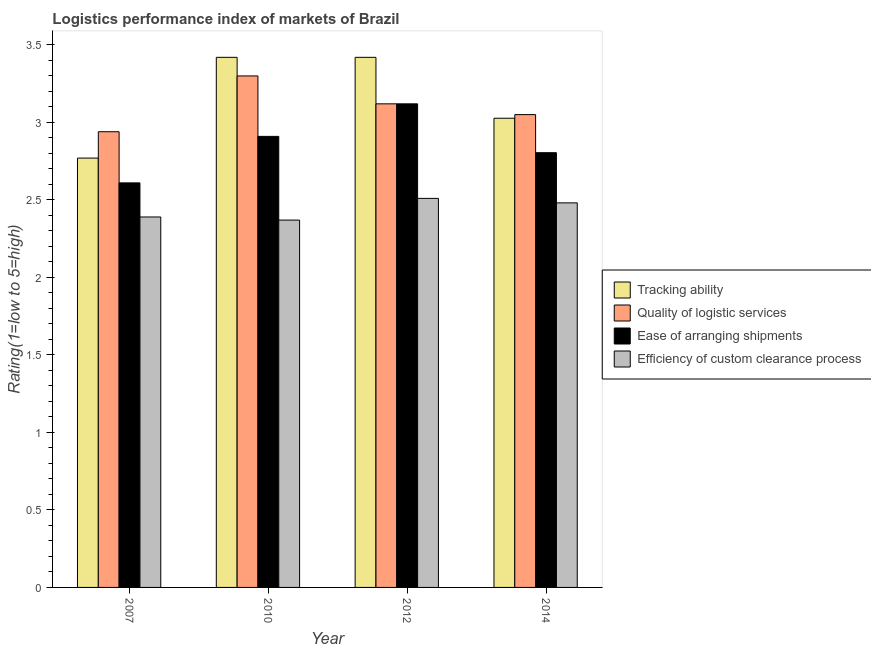How many different coloured bars are there?
Offer a very short reply. 4. Are the number of bars on each tick of the X-axis equal?
Keep it short and to the point. Yes. What is the label of the 4th group of bars from the left?
Your answer should be very brief. 2014. What is the lpi rating of efficiency of custom clearance process in 2012?
Ensure brevity in your answer.  2.51. Across all years, what is the maximum lpi rating of efficiency of custom clearance process?
Provide a succinct answer. 2.51. Across all years, what is the minimum lpi rating of quality of logistic services?
Make the answer very short. 2.94. In which year was the lpi rating of efficiency of custom clearance process maximum?
Your response must be concise. 2012. In which year was the lpi rating of ease of arranging shipments minimum?
Your answer should be compact. 2007. What is the total lpi rating of tracking ability in the graph?
Offer a very short reply. 12.64. What is the difference between the lpi rating of efficiency of custom clearance process in 2010 and that in 2012?
Offer a terse response. -0.14. What is the difference between the lpi rating of tracking ability in 2014 and the lpi rating of quality of logistic services in 2007?
Offer a terse response. 0.26. What is the average lpi rating of efficiency of custom clearance process per year?
Your answer should be compact. 2.44. In the year 2010, what is the difference between the lpi rating of tracking ability and lpi rating of ease of arranging shipments?
Keep it short and to the point. 0. In how many years, is the lpi rating of ease of arranging shipments greater than 2.8?
Ensure brevity in your answer.  3. What is the ratio of the lpi rating of quality of logistic services in 2010 to that in 2012?
Your answer should be compact. 1.06. Is the difference between the lpi rating of ease of arranging shipments in 2012 and 2014 greater than the difference between the lpi rating of tracking ability in 2012 and 2014?
Give a very brief answer. No. What is the difference between the highest and the second highest lpi rating of ease of arranging shipments?
Your response must be concise. 0.21. What is the difference between the highest and the lowest lpi rating of tracking ability?
Provide a short and direct response. 0.65. In how many years, is the lpi rating of tracking ability greater than the average lpi rating of tracking ability taken over all years?
Provide a succinct answer. 2. Is it the case that in every year, the sum of the lpi rating of ease of arranging shipments and lpi rating of tracking ability is greater than the sum of lpi rating of efficiency of custom clearance process and lpi rating of quality of logistic services?
Give a very brief answer. No. What does the 4th bar from the left in 2012 represents?
Give a very brief answer. Efficiency of custom clearance process. What does the 3rd bar from the right in 2012 represents?
Provide a succinct answer. Quality of logistic services. Is it the case that in every year, the sum of the lpi rating of tracking ability and lpi rating of quality of logistic services is greater than the lpi rating of ease of arranging shipments?
Your response must be concise. Yes. How many bars are there?
Your answer should be compact. 16. Are all the bars in the graph horizontal?
Make the answer very short. No. Are the values on the major ticks of Y-axis written in scientific E-notation?
Ensure brevity in your answer.  No. Where does the legend appear in the graph?
Provide a succinct answer. Center right. How are the legend labels stacked?
Your answer should be very brief. Vertical. What is the title of the graph?
Your answer should be very brief. Logistics performance index of markets of Brazil. Does "Japan" appear as one of the legend labels in the graph?
Provide a short and direct response. No. What is the label or title of the Y-axis?
Provide a succinct answer. Rating(1=low to 5=high). What is the Rating(1=low to 5=high) of Tracking ability in 2007?
Keep it short and to the point. 2.77. What is the Rating(1=low to 5=high) in Quality of logistic services in 2007?
Provide a succinct answer. 2.94. What is the Rating(1=low to 5=high) in Ease of arranging shipments in 2007?
Offer a very short reply. 2.61. What is the Rating(1=low to 5=high) in Efficiency of custom clearance process in 2007?
Offer a terse response. 2.39. What is the Rating(1=low to 5=high) in Tracking ability in 2010?
Offer a very short reply. 3.42. What is the Rating(1=low to 5=high) in Quality of logistic services in 2010?
Your answer should be very brief. 3.3. What is the Rating(1=low to 5=high) of Ease of arranging shipments in 2010?
Provide a short and direct response. 2.91. What is the Rating(1=low to 5=high) in Efficiency of custom clearance process in 2010?
Provide a short and direct response. 2.37. What is the Rating(1=low to 5=high) of Tracking ability in 2012?
Give a very brief answer. 3.42. What is the Rating(1=low to 5=high) of Quality of logistic services in 2012?
Provide a succinct answer. 3.12. What is the Rating(1=low to 5=high) of Ease of arranging shipments in 2012?
Your answer should be compact. 3.12. What is the Rating(1=low to 5=high) of Efficiency of custom clearance process in 2012?
Your response must be concise. 2.51. What is the Rating(1=low to 5=high) in Tracking ability in 2014?
Make the answer very short. 3.03. What is the Rating(1=low to 5=high) of Quality of logistic services in 2014?
Keep it short and to the point. 3.05. What is the Rating(1=low to 5=high) in Ease of arranging shipments in 2014?
Offer a very short reply. 2.8. What is the Rating(1=low to 5=high) in Efficiency of custom clearance process in 2014?
Offer a very short reply. 2.48. Across all years, what is the maximum Rating(1=low to 5=high) of Tracking ability?
Your response must be concise. 3.42. Across all years, what is the maximum Rating(1=low to 5=high) in Ease of arranging shipments?
Your answer should be very brief. 3.12. Across all years, what is the maximum Rating(1=low to 5=high) in Efficiency of custom clearance process?
Provide a succinct answer. 2.51. Across all years, what is the minimum Rating(1=low to 5=high) in Tracking ability?
Give a very brief answer. 2.77. Across all years, what is the minimum Rating(1=low to 5=high) in Quality of logistic services?
Your answer should be compact. 2.94. Across all years, what is the minimum Rating(1=low to 5=high) in Ease of arranging shipments?
Your answer should be compact. 2.61. Across all years, what is the minimum Rating(1=low to 5=high) of Efficiency of custom clearance process?
Your answer should be very brief. 2.37. What is the total Rating(1=low to 5=high) of Tracking ability in the graph?
Your answer should be compact. 12.64. What is the total Rating(1=low to 5=high) in Quality of logistic services in the graph?
Offer a very short reply. 12.41. What is the total Rating(1=low to 5=high) in Ease of arranging shipments in the graph?
Provide a succinct answer. 11.44. What is the total Rating(1=low to 5=high) in Efficiency of custom clearance process in the graph?
Your answer should be very brief. 9.75. What is the difference between the Rating(1=low to 5=high) of Tracking ability in 2007 and that in 2010?
Offer a terse response. -0.65. What is the difference between the Rating(1=low to 5=high) of Quality of logistic services in 2007 and that in 2010?
Offer a terse response. -0.36. What is the difference between the Rating(1=low to 5=high) in Ease of arranging shipments in 2007 and that in 2010?
Make the answer very short. -0.3. What is the difference between the Rating(1=low to 5=high) of Tracking ability in 2007 and that in 2012?
Give a very brief answer. -0.65. What is the difference between the Rating(1=low to 5=high) in Quality of logistic services in 2007 and that in 2012?
Your answer should be compact. -0.18. What is the difference between the Rating(1=low to 5=high) of Ease of arranging shipments in 2007 and that in 2012?
Keep it short and to the point. -0.51. What is the difference between the Rating(1=low to 5=high) of Efficiency of custom clearance process in 2007 and that in 2012?
Keep it short and to the point. -0.12. What is the difference between the Rating(1=low to 5=high) in Tracking ability in 2007 and that in 2014?
Ensure brevity in your answer.  -0.26. What is the difference between the Rating(1=low to 5=high) in Quality of logistic services in 2007 and that in 2014?
Your response must be concise. -0.11. What is the difference between the Rating(1=low to 5=high) in Ease of arranging shipments in 2007 and that in 2014?
Offer a very short reply. -0.19. What is the difference between the Rating(1=low to 5=high) in Efficiency of custom clearance process in 2007 and that in 2014?
Ensure brevity in your answer.  -0.09. What is the difference between the Rating(1=low to 5=high) in Quality of logistic services in 2010 and that in 2012?
Make the answer very short. 0.18. What is the difference between the Rating(1=low to 5=high) in Ease of arranging shipments in 2010 and that in 2012?
Your response must be concise. -0.21. What is the difference between the Rating(1=low to 5=high) in Efficiency of custom clearance process in 2010 and that in 2012?
Give a very brief answer. -0.14. What is the difference between the Rating(1=low to 5=high) of Tracking ability in 2010 and that in 2014?
Ensure brevity in your answer.  0.39. What is the difference between the Rating(1=low to 5=high) of Quality of logistic services in 2010 and that in 2014?
Your answer should be compact. 0.25. What is the difference between the Rating(1=low to 5=high) of Ease of arranging shipments in 2010 and that in 2014?
Keep it short and to the point. 0.11. What is the difference between the Rating(1=low to 5=high) of Efficiency of custom clearance process in 2010 and that in 2014?
Your answer should be compact. -0.11. What is the difference between the Rating(1=low to 5=high) in Tracking ability in 2012 and that in 2014?
Make the answer very short. 0.39. What is the difference between the Rating(1=low to 5=high) in Quality of logistic services in 2012 and that in 2014?
Offer a very short reply. 0.07. What is the difference between the Rating(1=low to 5=high) in Ease of arranging shipments in 2012 and that in 2014?
Give a very brief answer. 0.32. What is the difference between the Rating(1=low to 5=high) of Efficiency of custom clearance process in 2012 and that in 2014?
Ensure brevity in your answer.  0.03. What is the difference between the Rating(1=low to 5=high) in Tracking ability in 2007 and the Rating(1=low to 5=high) in Quality of logistic services in 2010?
Your answer should be compact. -0.53. What is the difference between the Rating(1=low to 5=high) in Tracking ability in 2007 and the Rating(1=low to 5=high) in Ease of arranging shipments in 2010?
Give a very brief answer. -0.14. What is the difference between the Rating(1=low to 5=high) in Tracking ability in 2007 and the Rating(1=low to 5=high) in Efficiency of custom clearance process in 2010?
Offer a terse response. 0.4. What is the difference between the Rating(1=low to 5=high) of Quality of logistic services in 2007 and the Rating(1=low to 5=high) of Efficiency of custom clearance process in 2010?
Provide a short and direct response. 0.57. What is the difference between the Rating(1=low to 5=high) of Ease of arranging shipments in 2007 and the Rating(1=low to 5=high) of Efficiency of custom clearance process in 2010?
Your answer should be compact. 0.24. What is the difference between the Rating(1=low to 5=high) in Tracking ability in 2007 and the Rating(1=low to 5=high) in Quality of logistic services in 2012?
Give a very brief answer. -0.35. What is the difference between the Rating(1=low to 5=high) of Tracking ability in 2007 and the Rating(1=low to 5=high) of Ease of arranging shipments in 2012?
Provide a succinct answer. -0.35. What is the difference between the Rating(1=low to 5=high) in Tracking ability in 2007 and the Rating(1=low to 5=high) in Efficiency of custom clearance process in 2012?
Provide a succinct answer. 0.26. What is the difference between the Rating(1=low to 5=high) of Quality of logistic services in 2007 and the Rating(1=low to 5=high) of Ease of arranging shipments in 2012?
Offer a terse response. -0.18. What is the difference between the Rating(1=low to 5=high) of Quality of logistic services in 2007 and the Rating(1=low to 5=high) of Efficiency of custom clearance process in 2012?
Offer a terse response. 0.43. What is the difference between the Rating(1=low to 5=high) in Ease of arranging shipments in 2007 and the Rating(1=low to 5=high) in Efficiency of custom clearance process in 2012?
Give a very brief answer. 0.1. What is the difference between the Rating(1=low to 5=high) of Tracking ability in 2007 and the Rating(1=low to 5=high) of Quality of logistic services in 2014?
Ensure brevity in your answer.  -0.28. What is the difference between the Rating(1=low to 5=high) of Tracking ability in 2007 and the Rating(1=low to 5=high) of Ease of arranging shipments in 2014?
Offer a terse response. -0.03. What is the difference between the Rating(1=low to 5=high) in Tracking ability in 2007 and the Rating(1=low to 5=high) in Efficiency of custom clearance process in 2014?
Offer a terse response. 0.29. What is the difference between the Rating(1=low to 5=high) of Quality of logistic services in 2007 and the Rating(1=low to 5=high) of Ease of arranging shipments in 2014?
Provide a short and direct response. 0.14. What is the difference between the Rating(1=low to 5=high) of Quality of logistic services in 2007 and the Rating(1=low to 5=high) of Efficiency of custom clearance process in 2014?
Make the answer very short. 0.46. What is the difference between the Rating(1=low to 5=high) in Ease of arranging shipments in 2007 and the Rating(1=low to 5=high) in Efficiency of custom clearance process in 2014?
Offer a terse response. 0.13. What is the difference between the Rating(1=low to 5=high) of Tracking ability in 2010 and the Rating(1=low to 5=high) of Quality of logistic services in 2012?
Your answer should be compact. 0.3. What is the difference between the Rating(1=low to 5=high) of Tracking ability in 2010 and the Rating(1=low to 5=high) of Ease of arranging shipments in 2012?
Make the answer very short. 0.3. What is the difference between the Rating(1=low to 5=high) in Tracking ability in 2010 and the Rating(1=low to 5=high) in Efficiency of custom clearance process in 2012?
Make the answer very short. 0.91. What is the difference between the Rating(1=low to 5=high) of Quality of logistic services in 2010 and the Rating(1=low to 5=high) of Ease of arranging shipments in 2012?
Your answer should be very brief. 0.18. What is the difference between the Rating(1=low to 5=high) of Quality of logistic services in 2010 and the Rating(1=low to 5=high) of Efficiency of custom clearance process in 2012?
Offer a terse response. 0.79. What is the difference between the Rating(1=low to 5=high) of Tracking ability in 2010 and the Rating(1=low to 5=high) of Quality of logistic services in 2014?
Offer a terse response. 0.37. What is the difference between the Rating(1=low to 5=high) in Tracking ability in 2010 and the Rating(1=low to 5=high) in Ease of arranging shipments in 2014?
Provide a short and direct response. 0.62. What is the difference between the Rating(1=low to 5=high) in Tracking ability in 2010 and the Rating(1=low to 5=high) in Efficiency of custom clearance process in 2014?
Provide a short and direct response. 0.94. What is the difference between the Rating(1=low to 5=high) of Quality of logistic services in 2010 and the Rating(1=low to 5=high) of Ease of arranging shipments in 2014?
Your response must be concise. 0.5. What is the difference between the Rating(1=low to 5=high) of Quality of logistic services in 2010 and the Rating(1=low to 5=high) of Efficiency of custom clearance process in 2014?
Keep it short and to the point. 0.82. What is the difference between the Rating(1=low to 5=high) of Ease of arranging shipments in 2010 and the Rating(1=low to 5=high) of Efficiency of custom clearance process in 2014?
Keep it short and to the point. 0.43. What is the difference between the Rating(1=low to 5=high) in Tracking ability in 2012 and the Rating(1=low to 5=high) in Quality of logistic services in 2014?
Ensure brevity in your answer.  0.37. What is the difference between the Rating(1=low to 5=high) of Tracking ability in 2012 and the Rating(1=low to 5=high) of Ease of arranging shipments in 2014?
Offer a terse response. 0.62. What is the difference between the Rating(1=low to 5=high) in Tracking ability in 2012 and the Rating(1=low to 5=high) in Efficiency of custom clearance process in 2014?
Make the answer very short. 0.94. What is the difference between the Rating(1=low to 5=high) in Quality of logistic services in 2012 and the Rating(1=low to 5=high) in Ease of arranging shipments in 2014?
Offer a terse response. 0.32. What is the difference between the Rating(1=low to 5=high) in Quality of logistic services in 2012 and the Rating(1=low to 5=high) in Efficiency of custom clearance process in 2014?
Keep it short and to the point. 0.64. What is the difference between the Rating(1=low to 5=high) in Ease of arranging shipments in 2012 and the Rating(1=low to 5=high) in Efficiency of custom clearance process in 2014?
Ensure brevity in your answer.  0.64. What is the average Rating(1=low to 5=high) of Tracking ability per year?
Your response must be concise. 3.16. What is the average Rating(1=low to 5=high) in Quality of logistic services per year?
Offer a very short reply. 3.1. What is the average Rating(1=low to 5=high) in Ease of arranging shipments per year?
Your response must be concise. 2.86. What is the average Rating(1=low to 5=high) of Efficiency of custom clearance process per year?
Give a very brief answer. 2.44. In the year 2007, what is the difference between the Rating(1=low to 5=high) of Tracking ability and Rating(1=low to 5=high) of Quality of logistic services?
Your answer should be very brief. -0.17. In the year 2007, what is the difference between the Rating(1=low to 5=high) in Tracking ability and Rating(1=low to 5=high) in Ease of arranging shipments?
Your response must be concise. 0.16. In the year 2007, what is the difference between the Rating(1=low to 5=high) in Tracking ability and Rating(1=low to 5=high) in Efficiency of custom clearance process?
Your response must be concise. 0.38. In the year 2007, what is the difference between the Rating(1=low to 5=high) of Quality of logistic services and Rating(1=low to 5=high) of Ease of arranging shipments?
Offer a very short reply. 0.33. In the year 2007, what is the difference between the Rating(1=low to 5=high) of Quality of logistic services and Rating(1=low to 5=high) of Efficiency of custom clearance process?
Offer a terse response. 0.55. In the year 2007, what is the difference between the Rating(1=low to 5=high) in Ease of arranging shipments and Rating(1=low to 5=high) in Efficiency of custom clearance process?
Offer a terse response. 0.22. In the year 2010, what is the difference between the Rating(1=low to 5=high) of Tracking ability and Rating(1=low to 5=high) of Quality of logistic services?
Provide a succinct answer. 0.12. In the year 2010, what is the difference between the Rating(1=low to 5=high) of Tracking ability and Rating(1=low to 5=high) of Ease of arranging shipments?
Make the answer very short. 0.51. In the year 2010, what is the difference between the Rating(1=low to 5=high) in Quality of logistic services and Rating(1=low to 5=high) in Ease of arranging shipments?
Make the answer very short. 0.39. In the year 2010, what is the difference between the Rating(1=low to 5=high) of Ease of arranging shipments and Rating(1=low to 5=high) of Efficiency of custom clearance process?
Ensure brevity in your answer.  0.54. In the year 2012, what is the difference between the Rating(1=low to 5=high) in Tracking ability and Rating(1=low to 5=high) in Quality of logistic services?
Your answer should be compact. 0.3. In the year 2012, what is the difference between the Rating(1=low to 5=high) of Tracking ability and Rating(1=low to 5=high) of Ease of arranging shipments?
Offer a very short reply. 0.3. In the year 2012, what is the difference between the Rating(1=low to 5=high) in Tracking ability and Rating(1=low to 5=high) in Efficiency of custom clearance process?
Provide a short and direct response. 0.91. In the year 2012, what is the difference between the Rating(1=low to 5=high) of Quality of logistic services and Rating(1=low to 5=high) of Ease of arranging shipments?
Give a very brief answer. 0. In the year 2012, what is the difference between the Rating(1=low to 5=high) in Quality of logistic services and Rating(1=low to 5=high) in Efficiency of custom clearance process?
Ensure brevity in your answer.  0.61. In the year 2012, what is the difference between the Rating(1=low to 5=high) in Ease of arranging shipments and Rating(1=low to 5=high) in Efficiency of custom clearance process?
Make the answer very short. 0.61. In the year 2014, what is the difference between the Rating(1=low to 5=high) in Tracking ability and Rating(1=low to 5=high) in Quality of logistic services?
Offer a terse response. -0.02. In the year 2014, what is the difference between the Rating(1=low to 5=high) in Tracking ability and Rating(1=low to 5=high) in Ease of arranging shipments?
Make the answer very short. 0.22. In the year 2014, what is the difference between the Rating(1=low to 5=high) in Tracking ability and Rating(1=low to 5=high) in Efficiency of custom clearance process?
Keep it short and to the point. 0.55. In the year 2014, what is the difference between the Rating(1=low to 5=high) in Quality of logistic services and Rating(1=low to 5=high) in Ease of arranging shipments?
Give a very brief answer. 0.25. In the year 2014, what is the difference between the Rating(1=low to 5=high) of Quality of logistic services and Rating(1=low to 5=high) of Efficiency of custom clearance process?
Your answer should be compact. 0.57. In the year 2014, what is the difference between the Rating(1=low to 5=high) of Ease of arranging shipments and Rating(1=low to 5=high) of Efficiency of custom clearance process?
Offer a terse response. 0.32. What is the ratio of the Rating(1=low to 5=high) in Tracking ability in 2007 to that in 2010?
Offer a terse response. 0.81. What is the ratio of the Rating(1=low to 5=high) of Quality of logistic services in 2007 to that in 2010?
Your answer should be very brief. 0.89. What is the ratio of the Rating(1=low to 5=high) in Ease of arranging shipments in 2007 to that in 2010?
Give a very brief answer. 0.9. What is the ratio of the Rating(1=low to 5=high) of Efficiency of custom clearance process in 2007 to that in 2010?
Give a very brief answer. 1.01. What is the ratio of the Rating(1=low to 5=high) of Tracking ability in 2007 to that in 2012?
Your response must be concise. 0.81. What is the ratio of the Rating(1=low to 5=high) of Quality of logistic services in 2007 to that in 2012?
Provide a succinct answer. 0.94. What is the ratio of the Rating(1=low to 5=high) in Ease of arranging shipments in 2007 to that in 2012?
Make the answer very short. 0.84. What is the ratio of the Rating(1=low to 5=high) of Efficiency of custom clearance process in 2007 to that in 2012?
Provide a succinct answer. 0.95. What is the ratio of the Rating(1=low to 5=high) of Tracking ability in 2007 to that in 2014?
Your answer should be very brief. 0.92. What is the ratio of the Rating(1=low to 5=high) of Quality of logistic services in 2007 to that in 2014?
Provide a short and direct response. 0.96. What is the ratio of the Rating(1=low to 5=high) of Ease of arranging shipments in 2007 to that in 2014?
Your answer should be very brief. 0.93. What is the ratio of the Rating(1=low to 5=high) of Efficiency of custom clearance process in 2007 to that in 2014?
Give a very brief answer. 0.96. What is the ratio of the Rating(1=low to 5=high) of Tracking ability in 2010 to that in 2012?
Provide a succinct answer. 1. What is the ratio of the Rating(1=low to 5=high) in Quality of logistic services in 2010 to that in 2012?
Your response must be concise. 1.06. What is the ratio of the Rating(1=low to 5=high) of Ease of arranging shipments in 2010 to that in 2012?
Keep it short and to the point. 0.93. What is the ratio of the Rating(1=low to 5=high) in Efficiency of custom clearance process in 2010 to that in 2012?
Your answer should be compact. 0.94. What is the ratio of the Rating(1=low to 5=high) of Tracking ability in 2010 to that in 2014?
Give a very brief answer. 1.13. What is the ratio of the Rating(1=low to 5=high) in Quality of logistic services in 2010 to that in 2014?
Make the answer very short. 1.08. What is the ratio of the Rating(1=low to 5=high) of Ease of arranging shipments in 2010 to that in 2014?
Your answer should be compact. 1.04. What is the ratio of the Rating(1=low to 5=high) of Efficiency of custom clearance process in 2010 to that in 2014?
Make the answer very short. 0.96. What is the ratio of the Rating(1=low to 5=high) in Tracking ability in 2012 to that in 2014?
Your response must be concise. 1.13. What is the ratio of the Rating(1=low to 5=high) of Quality of logistic services in 2012 to that in 2014?
Provide a succinct answer. 1.02. What is the ratio of the Rating(1=low to 5=high) of Ease of arranging shipments in 2012 to that in 2014?
Keep it short and to the point. 1.11. What is the ratio of the Rating(1=low to 5=high) of Efficiency of custom clearance process in 2012 to that in 2014?
Offer a very short reply. 1.01. What is the difference between the highest and the second highest Rating(1=low to 5=high) of Quality of logistic services?
Offer a terse response. 0.18. What is the difference between the highest and the second highest Rating(1=low to 5=high) of Ease of arranging shipments?
Make the answer very short. 0.21. What is the difference between the highest and the second highest Rating(1=low to 5=high) in Efficiency of custom clearance process?
Provide a short and direct response. 0.03. What is the difference between the highest and the lowest Rating(1=low to 5=high) in Tracking ability?
Provide a succinct answer. 0.65. What is the difference between the highest and the lowest Rating(1=low to 5=high) of Quality of logistic services?
Your answer should be very brief. 0.36. What is the difference between the highest and the lowest Rating(1=low to 5=high) in Ease of arranging shipments?
Your response must be concise. 0.51. What is the difference between the highest and the lowest Rating(1=low to 5=high) in Efficiency of custom clearance process?
Provide a succinct answer. 0.14. 